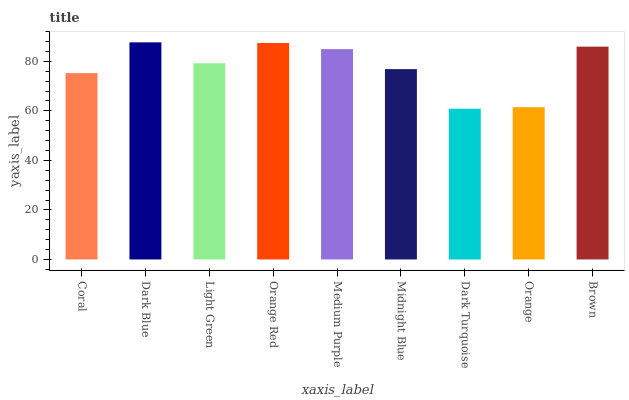Is Dark Turquoise the minimum?
Answer yes or no. Yes. Is Dark Blue the maximum?
Answer yes or no. Yes. Is Light Green the minimum?
Answer yes or no. No. Is Light Green the maximum?
Answer yes or no. No. Is Dark Blue greater than Light Green?
Answer yes or no. Yes. Is Light Green less than Dark Blue?
Answer yes or no. Yes. Is Light Green greater than Dark Blue?
Answer yes or no. No. Is Dark Blue less than Light Green?
Answer yes or no. No. Is Light Green the high median?
Answer yes or no. Yes. Is Light Green the low median?
Answer yes or no. Yes. Is Orange Red the high median?
Answer yes or no. No. Is Orange Red the low median?
Answer yes or no. No. 